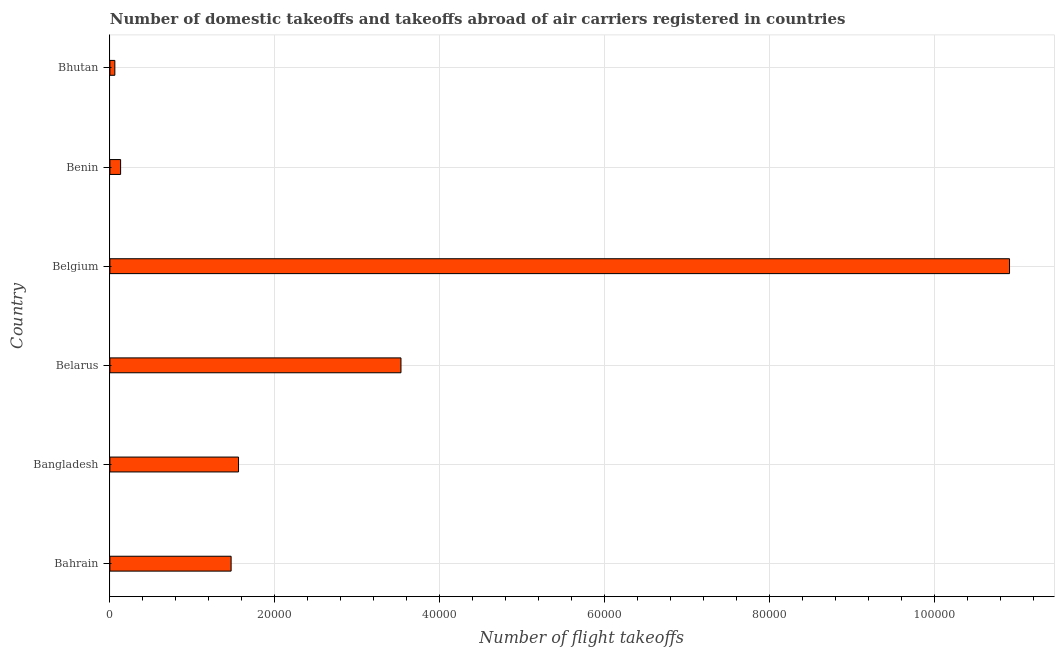Does the graph contain any zero values?
Make the answer very short. No. What is the title of the graph?
Offer a very short reply. Number of domestic takeoffs and takeoffs abroad of air carriers registered in countries. What is the label or title of the X-axis?
Offer a very short reply. Number of flight takeoffs. What is the number of flight takeoffs in Belgium?
Ensure brevity in your answer.  1.09e+05. Across all countries, what is the maximum number of flight takeoffs?
Make the answer very short. 1.09e+05. Across all countries, what is the minimum number of flight takeoffs?
Your answer should be very brief. 600. In which country was the number of flight takeoffs maximum?
Offer a very short reply. Belgium. In which country was the number of flight takeoffs minimum?
Keep it short and to the point. Bhutan. What is the sum of the number of flight takeoffs?
Ensure brevity in your answer.  1.77e+05. What is the difference between the number of flight takeoffs in Bangladesh and Belgium?
Offer a very short reply. -9.35e+04. What is the average number of flight takeoffs per country?
Provide a short and direct response. 2.94e+04. What is the median number of flight takeoffs?
Make the answer very short. 1.52e+04. In how many countries, is the number of flight takeoffs greater than 72000 ?
Provide a succinct answer. 1. What is the ratio of the number of flight takeoffs in Belarus to that in Bhutan?
Give a very brief answer. 58.83. What is the difference between the highest and the second highest number of flight takeoffs?
Give a very brief answer. 7.38e+04. What is the difference between the highest and the lowest number of flight takeoffs?
Ensure brevity in your answer.  1.08e+05. In how many countries, is the number of flight takeoffs greater than the average number of flight takeoffs taken over all countries?
Make the answer very short. 2. Are all the bars in the graph horizontal?
Ensure brevity in your answer.  Yes. Are the values on the major ticks of X-axis written in scientific E-notation?
Offer a terse response. No. What is the Number of flight takeoffs of Bahrain?
Offer a very short reply. 1.47e+04. What is the Number of flight takeoffs of Bangladesh?
Provide a succinct answer. 1.56e+04. What is the Number of flight takeoffs in Belarus?
Ensure brevity in your answer.  3.53e+04. What is the Number of flight takeoffs in Belgium?
Keep it short and to the point. 1.09e+05. What is the Number of flight takeoffs in Benin?
Make the answer very short. 1300. What is the Number of flight takeoffs in Bhutan?
Make the answer very short. 600. What is the difference between the Number of flight takeoffs in Bahrain and Bangladesh?
Offer a very short reply. -900. What is the difference between the Number of flight takeoffs in Bahrain and Belarus?
Offer a very short reply. -2.06e+04. What is the difference between the Number of flight takeoffs in Bahrain and Belgium?
Your answer should be compact. -9.44e+04. What is the difference between the Number of flight takeoffs in Bahrain and Benin?
Keep it short and to the point. 1.34e+04. What is the difference between the Number of flight takeoffs in Bahrain and Bhutan?
Your answer should be compact. 1.41e+04. What is the difference between the Number of flight takeoffs in Bangladesh and Belarus?
Offer a very short reply. -1.97e+04. What is the difference between the Number of flight takeoffs in Bangladesh and Belgium?
Offer a very short reply. -9.35e+04. What is the difference between the Number of flight takeoffs in Bangladesh and Benin?
Your response must be concise. 1.43e+04. What is the difference between the Number of flight takeoffs in Bangladesh and Bhutan?
Your answer should be very brief. 1.50e+04. What is the difference between the Number of flight takeoffs in Belarus and Belgium?
Your answer should be compact. -7.38e+04. What is the difference between the Number of flight takeoffs in Belarus and Benin?
Provide a short and direct response. 3.40e+04. What is the difference between the Number of flight takeoffs in Belarus and Bhutan?
Provide a succinct answer. 3.47e+04. What is the difference between the Number of flight takeoffs in Belgium and Benin?
Give a very brief answer. 1.08e+05. What is the difference between the Number of flight takeoffs in Belgium and Bhutan?
Give a very brief answer. 1.08e+05. What is the difference between the Number of flight takeoffs in Benin and Bhutan?
Your answer should be compact. 700. What is the ratio of the Number of flight takeoffs in Bahrain to that in Bangladesh?
Your response must be concise. 0.94. What is the ratio of the Number of flight takeoffs in Bahrain to that in Belarus?
Provide a succinct answer. 0.42. What is the ratio of the Number of flight takeoffs in Bahrain to that in Belgium?
Your response must be concise. 0.14. What is the ratio of the Number of flight takeoffs in Bahrain to that in Benin?
Make the answer very short. 11.31. What is the ratio of the Number of flight takeoffs in Bahrain to that in Bhutan?
Your answer should be very brief. 24.5. What is the ratio of the Number of flight takeoffs in Bangladesh to that in Belarus?
Provide a succinct answer. 0.44. What is the ratio of the Number of flight takeoffs in Bangladesh to that in Belgium?
Give a very brief answer. 0.14. What is the ratio of the Number of flight takeoffs in Belarus to that in Belgium?
Your answer should be compact. 0.32. What is the ratio of the Number of flight takeoffs in Belarus to that in Benin?
Offer a terse response. 27.15. What is the ratio of the Number of flight takeoffs in Belarus to that in Bhutan?
Provide a short and direct response. 58.83. What is the ratio of the Number of flight takeoffs in Belgium to that in Benin?
Provide a succinct answer. 83.92. What is the ratio of the Number of flight takeoffs in Belgium to that in Bhutan?
Keep it short and to the point. 181.83. What is the ratio of the Number of flight takeoffs in Benin to that in Bhutan?
Offer a very short reply. 2.17. 